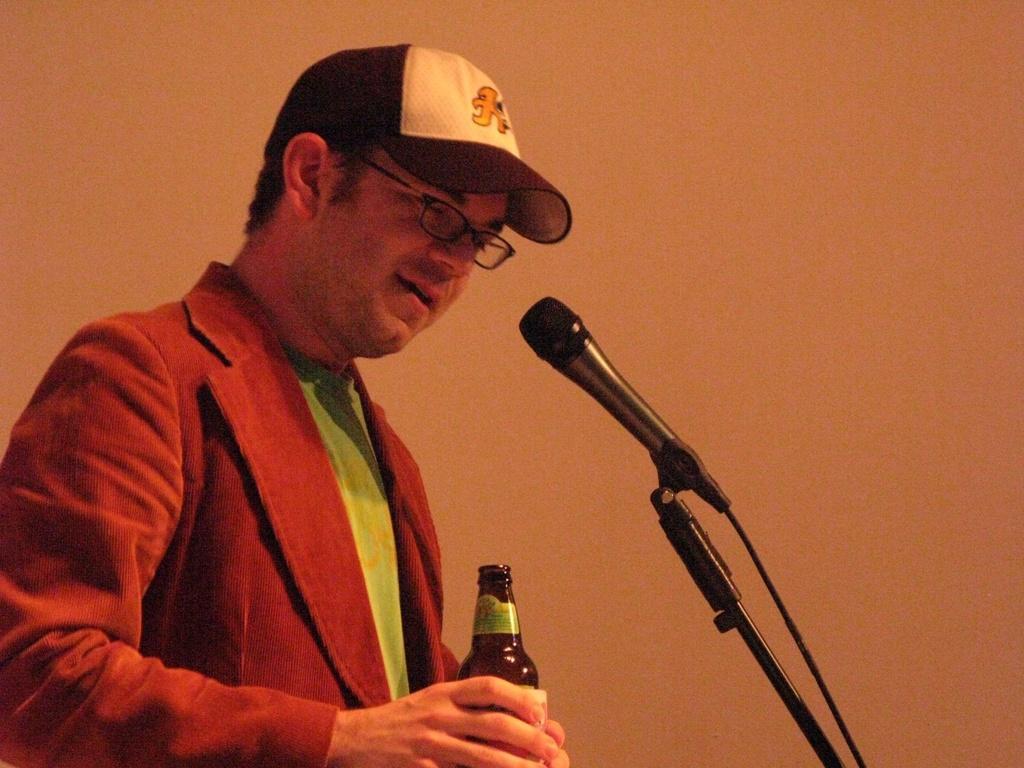Could you give a brief overview of what you see in this image? This picture is taken inside a room. On the left corner of the picture, we see a man in blue green t-shirt, is wearing a red blazer. He is carrying wine bottle in his hands, he is even wearing cap and spectacles. In front of him, we see microphone and I think he is talking on it. Behind him, we see a wall which is white in color. 